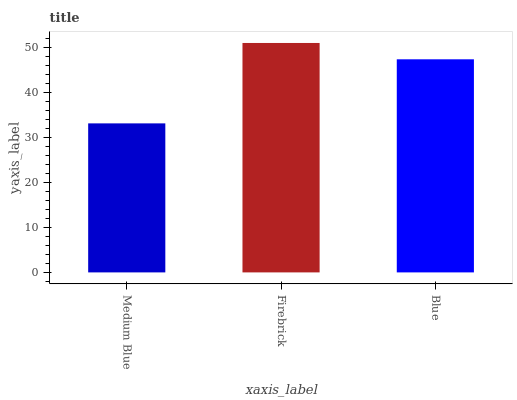Is Medium Blue the minimum?
Answer yes or no. Yes. Is Firebrick the maximum?
Answer yes or no. Yes. Is Blue the minimum?
Answer yes or no. No. Is Blue the maximum?
Answer yes or no. No. Is Firebrick greater than Blue?
Answer yes or no. Yes. Is Blue less than Firebrick?
Answer yes or no. Yes. Is Blue greater than Firebrick?
Answer yes or no. No. Is Firebrick less than Blue?
Answer yes or no. No. Is Blue the high median?
Answer yes or no. Yes. Is Blue the low median?
Answer yes or no. Yes. Is Medium Blue the high median?
Answer yes or no. No. Is Medium Blue the low median?
Answer yes or no. No. 